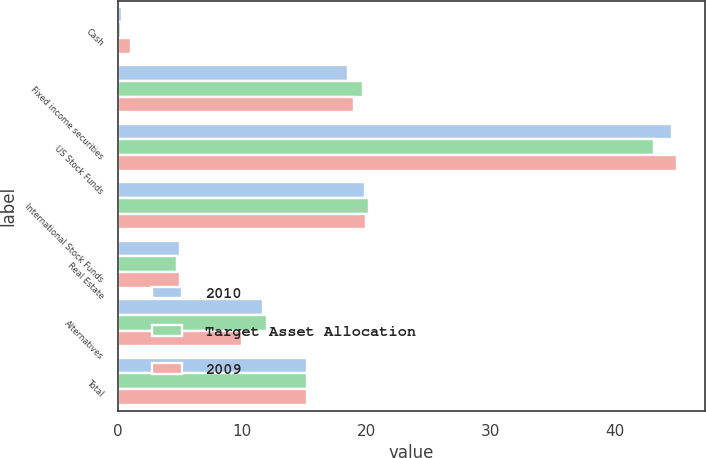Convert chart to OTSL. <chart><loc_0><loc_0><loc_500><loc_500><stacked_bar_chart><ecel><fcel>Cash<fcel>Fixed income securities<fcel>US Stock Funds<fcel>International Stock Funds<fcel>Real Estate<fcel>Alternatives<fcel>Total<nl><fcel>2010<fcel>0.3<fcel>18.5<fcel>44.6<fcel>19.9<fcel>5<fcel>11.7<fcel>15.25<nl><fcel>Target Asset Allocation<fcel>0.2<fcel>19.7<fcel>43.2<fcel>20.2<fcel>4.7<fcel>12<fcel>15.25<nl><fcel>2009<fcel>1<fcel>19<fcel>45<fcel>20<fcel>5<fcel>10<fcel>15.25<nl></chart> 